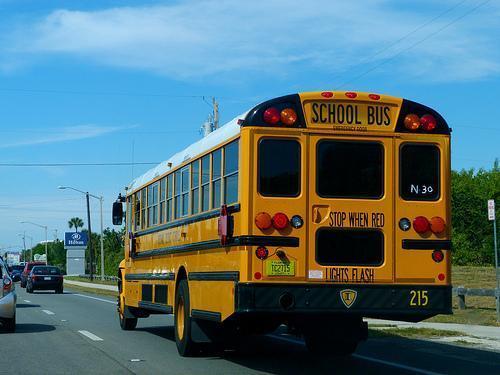How many orange lights are on the back of the bus?
Give a very brief answer. 4. How many windows are on the back of the bus?
Give a very brief answer. 4. 